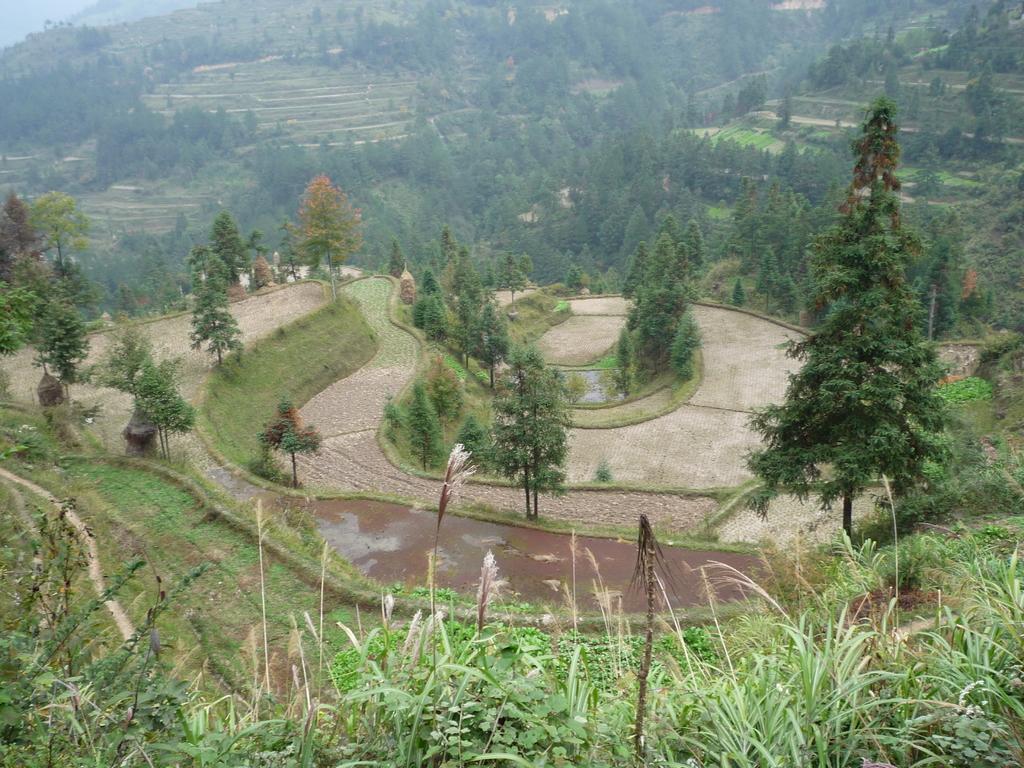Can you describe this image briefly? In this picture we can see trees and grass, in the top left we can see the sky. 